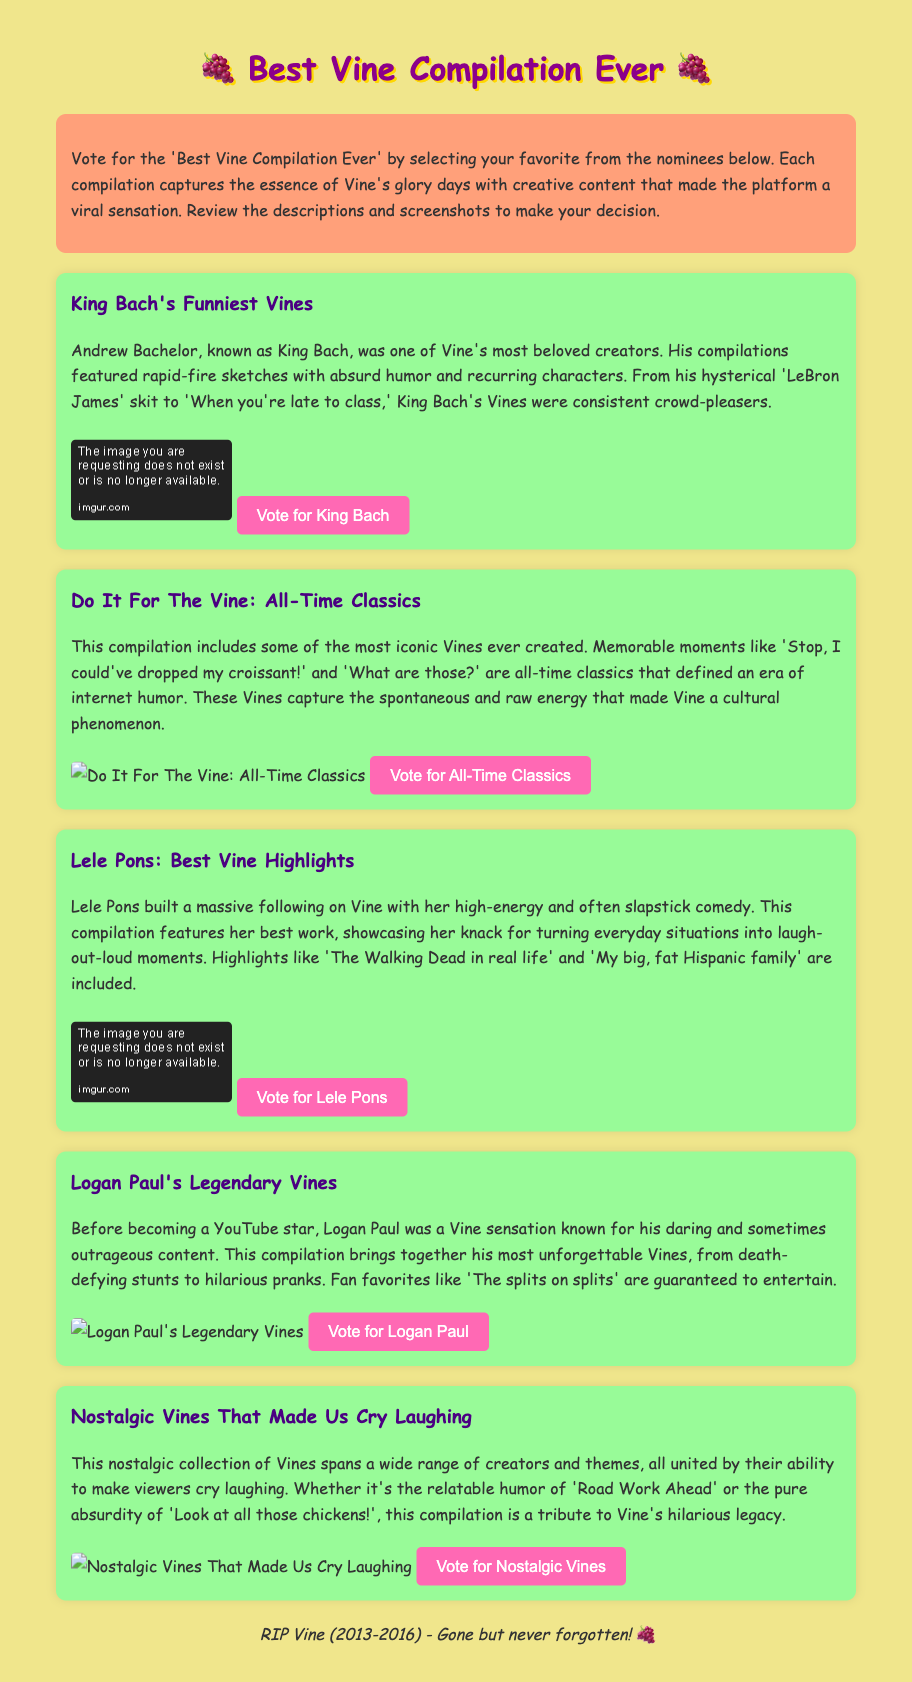what is the title of the ballot? The title is displayed prominently at the top of the document and is "Best Vine Compilation Ever."
Answer: Best Vine Compilation Ever who is known as King Bach? King Bach is the online persona of Andrew Bachelor, a prominent creator known for his Vines.
Answer: Andrew Bachelor which compilation features the Vine 'Stop, I could've dropped my croissant!'? The Vine is part of the compilation titled "Do It For The Vine: All-Time Classics."
Answer: Do It For The Vine: All-Time Classics how many nominations are listed in the document? The document presents a total of five nominations for the voting process.
Answer: Five what color is the background of the document? The background color of the document is a light yellow shade.
Answer: Light yellow which nomination includes the phrase 'The Walking Dead in real life'? This phrase is included in the nomination titled "Lele Pons: Best Vine Highlights."
Answer: Lele Pons: Best Vine Highlights what is the voting button color? The color of the voting buttons is pink.
Answer: Pink who has a skit about 'LeBron James'? The skit about 'LeBron James' is associated with King Bach.
Answer: King Bach what type of compilation is 'Nostalgic Vines That Made Us Cry Laughing'? This compilation can be categorized as a nostalgic collection of Vines.
Answer: Nostalgic collection 